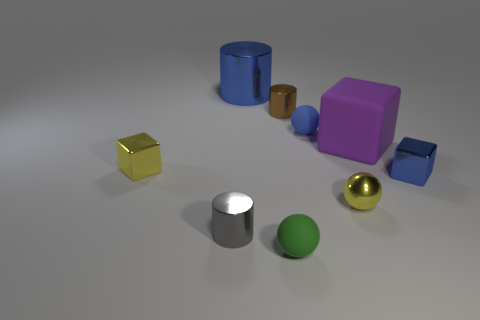There is a matte sphere that is behind the yellow metal block that is behind the gray cylinder; how many green things are behind it?
Make the answer very short. 0. There is a big cube; is it the same color as the small shiny cylinder on the left side of the big blue shiny object?
Your answer should be compact. No. The small metal thing that is the same color as the tiny shiny ball is what shape?
Make the answer very short. Cube. What material is the small cylinder in front of the metallic object that is left of the cylinder in front of the rubber block?
Give a very brief answer. Metal. Do the small yellow shiny thing that is on the left side of the tiny gray metallic cylinder and the gray metal thing have the same shape?
Make the answer very short. No. What is the tiny cylinder in front of the large purple matte object made of?
Your response must be concise. Metal. What number of metal things are large purple cubes or small brown things?
Your answer should be very brief. 1. Are there any blue metal cubes that have the same size as the green object?
Provide a short and direct response. Yes. Are there more tiny gray cylinders in front of the large cylinder than cyan metallic objects?
Provide a short and direct response. Yes. What number of tiny things are either brown objects or blue objects?
Ensure brevity in your answer.  3. 